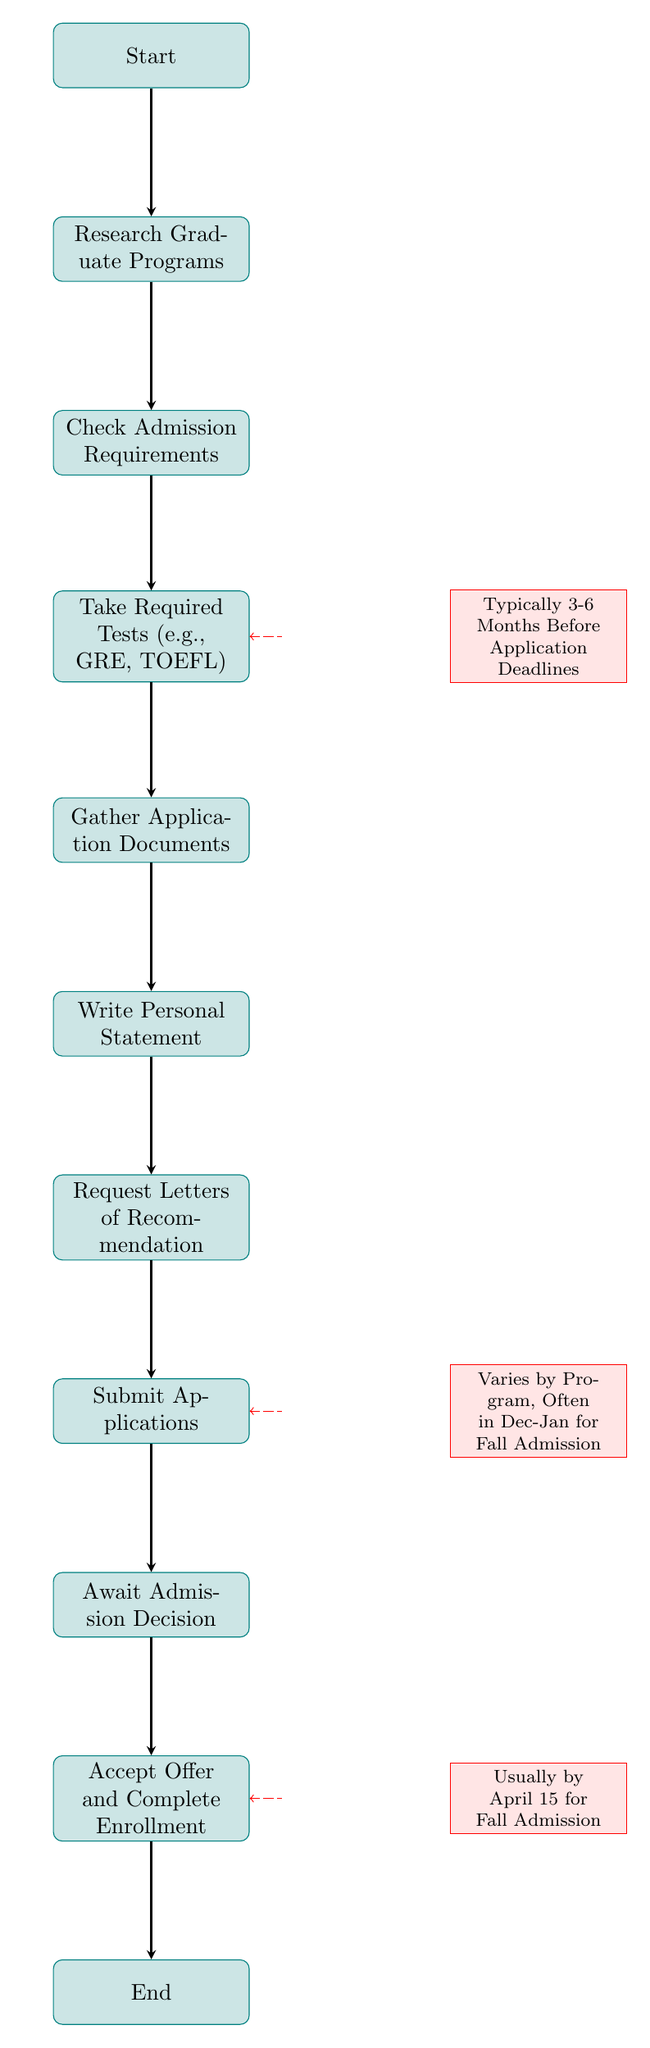What is the first step in the graduate application process? The first step in the flowchart is indicated by the node labeled "Start," which leads to the next process node. Therefore, the first step is the start of the entire process.
Answer: Start How many main process steps are there in the flowchart? Counting the nodes in the flowchart, there are nine main process steps from "Start" to "End" that detail each stage of the application process.
Answer: 9 What document must be written after gathering application documents? Once the application documents are gathered, the flowchart indicates that the next step is to "Write Personal Statement."
Answer: Write Personal Statement What happens after the "Submit Applications" step? The diagram shows a direct progression from "Submit Applications" to "Await Admission Decision," meaning that after submitting applications, the next action is to wait for the decision regarding admission.
Answer: Await Admission Decision When should the required tests be taken? The flowchart provides a note that states "Typically 3-6 Months Before Application Deadlines," indicating that tests should be completed in that timeframe relative to application deadlines.
Answer: Typically 3-6 Months Before Application Deadlines How do the application deadlines vary? The flowchart notes that deadlines vary by program, with a specific indication that they "Often in Dec-Jan for Fall Admission," making it clear that different programs may have different deadlines.
Answer: Varies by Program, Often in Dec-Jan for Fall Admission What is the deadline for accepting an admission offer? According to the diagram, the deadline provided states "Usually by April 15 for Fall Admission," which indicates the latest possible date to accept an admission offer.
Answer: Usually by April 15 for Fall Admission Which process step immediately follows "Request Letters of Recommendation"? The diagram indicates that "Submit Applications" follows immediately after "Request Letters of Recommendation," reflecting the sequential nature of these steps in the application process.
Answer: Submit Applications What type of diagram is this? This diagram is a flowchart which typically represents processes and workflows using nodes and arrows to indicate the progression of steps.
Answer: Flowchart 